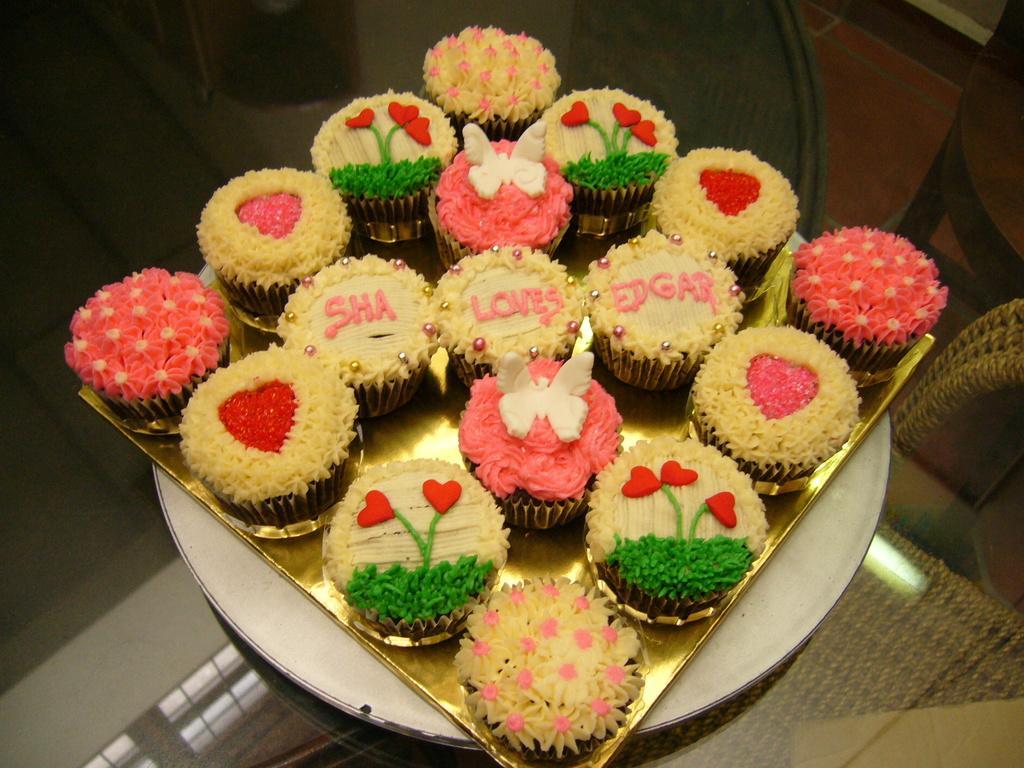In one or two sentences, can you explain what this image depicts? In this image, we can see cup cakes in the tray, which are placed on the table. 